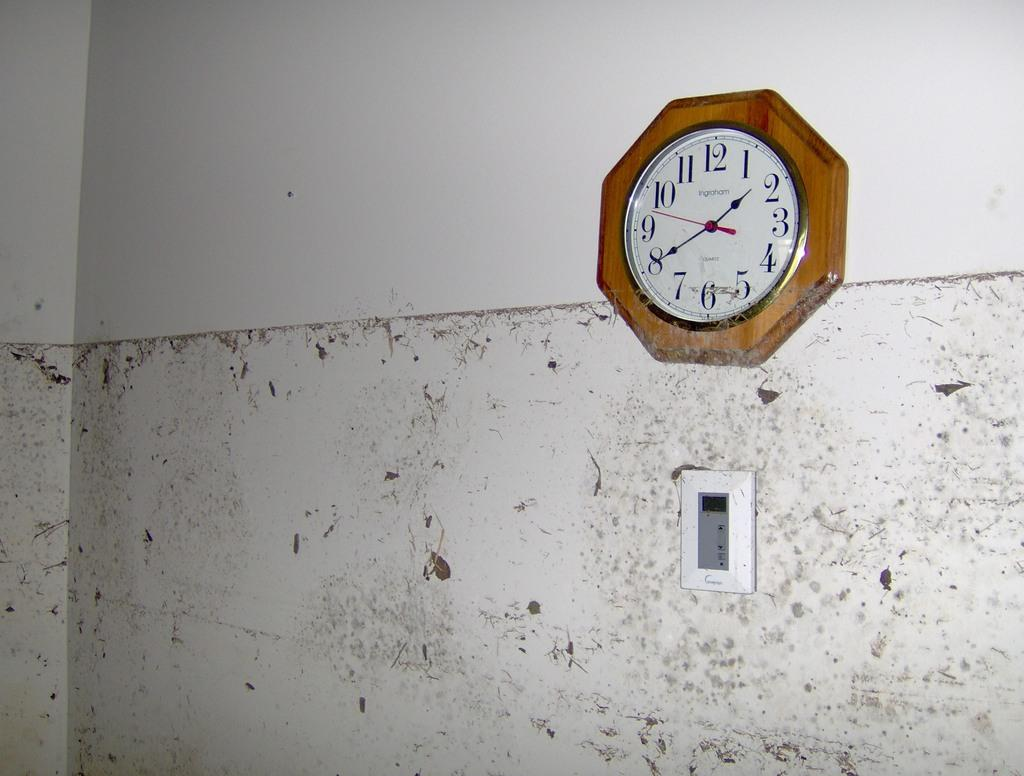<image>
Relay a brief, clear account of the picture shown. A wood rimmed clock on a white wall has the word Ingraham on its face above the center point. 